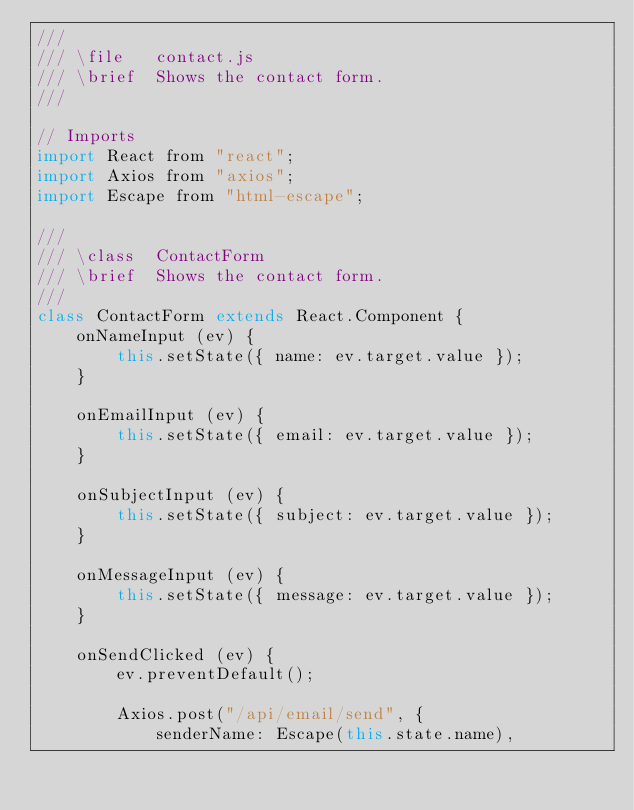Convert code to text. <code><loc_0><loc_0><loc_500><loc_500><_JavaScript_>///
/// \file   contact.js
/// \brief  Shows the contact form.
///

// Imports
import React from "react";
import Axios from "axios";
import Escape from "html-escape";

///
/// \class  ContactForm
/// \brief  Shows the contact form.
///
class ContactForm extends React.Component {
    onNameInput (ev) {
        this.setState({ name: ev.target.value });
    }

    onEmailInput (ev) {
        this.setState({ email: ev.target.value });
    }

    onSubjectInput (ev) {
        this.setState({ subject: ev.target.value });
    }

    onMessageInput (ev) {
        this.setState({ message: ev.target.value });
    }

    onSendClicked (ev) {
        ev.preventDefault();

        Axios.post("/api/email/send", {
            senderName: Escape(this.state.name),</code> 